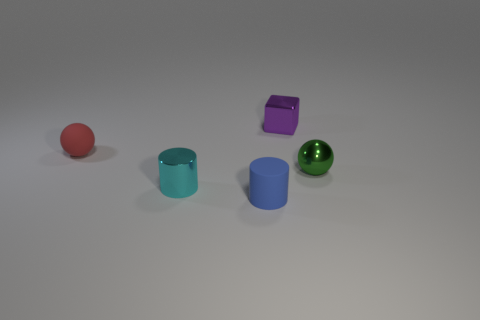The metal ball has what color?
Offer a terse response. Green. How many small objects are either cyan shiny objects or purple things?
Ensure brevity in your answer.  2. Is the object that is right of the purple metallic object made of the same material as the tiny ball left of the purple object?
Your answer should be compact. No. Are there any blue cylinders?
Your answer should be compact. Yes. Are there more things that are in front of the purple cube than blue matte cylinders to the right of the small blue rubber cylinder?
Your answer should be compact. Yes. There is a red object that is the same shape as the green thing; what is it made of?
Offer a very short reply. Rubber. There is a blue rubber thing; what shape is it?
Your answer should be compact. Cylinder. Are there more purple metal cubes that are in front of the shiny sphere than big red rubber cubes?
Provide a short and direct response. No. What shape is the small object that is on the right side of the purple metallic thing?
Keep it short and to the point. Sphere. What number of other things are there of the same shape as the tiny purple metallic thing?
Keep it short and to the point. 0. 